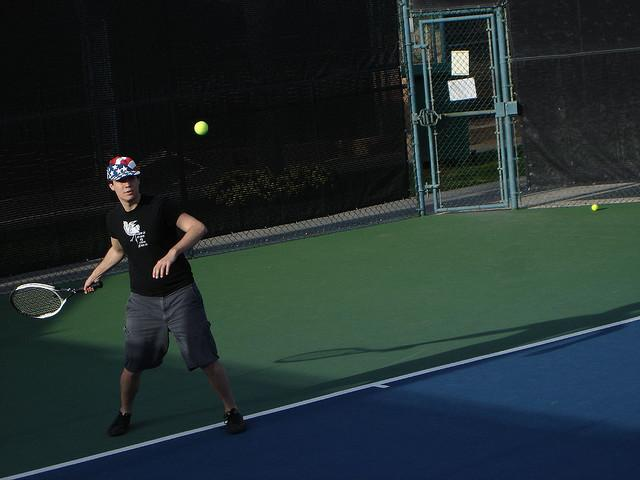Why is their hand held way back? Please explain your reasoning. swing ball. The hand is swinging the ball. 